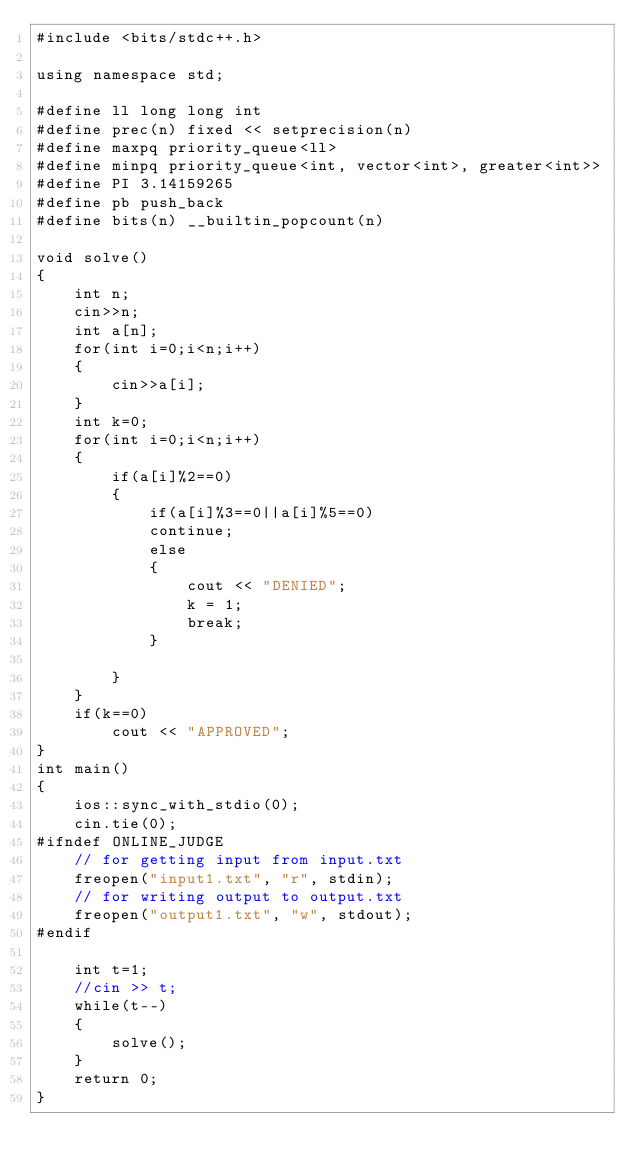Convert code to text. <code><loc_0><loc_0><loc_500><loc_500><_C++_>#include <bits/stdc++.h>

using namespace std;

#define ll long long int
#define prec(n) fixed << setprecision(n)
#define maxpq priority_queue<ll>
#define minpq priority_queue<int, vector<int>, greater<int>>
#define PI 3.14159265
#define pb push_back
#define bits(n) __builtin_popcount(n)

void solve()
{
    int n;
    cin>>n;
    int a[n];
    for(int i=0;i<n;i++)
    {
        cin>>a[i];
    }
    int k=0;
    for(int i=0;i<n;i++)
    {
        if(a[i]%2==0)
        {
            if(a[i]%3==0||a[i]%5==0)
            continue;
            else
            {
                cout << "DENIED";
                k = 1;
                break;
            }
            
        }
    }
    if(k==0)
        cout << "APPROVED";
}
int main()
{
    ios::sync_with_stdio(0);
    cin.tie(0);
#ifndef ONLINE_JUDGE
    // for getting input from input.txt
    freopen("input1.txt", "r", stdin);
    // for writing output to output.txt
    freopen("output1.txt", "w", stdout);
#endif

    int t=1;
    //cin >> t;
    while(t--)
    {
        solve();
    }
    return 0;
}</code> 